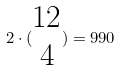<formula> <loc_0><loc_0><loc_500><loc_500>2 \cdot ( \begin{matrix} 1 2 \\ 4 \end{matrix} ) = 9 9 0</formula> 